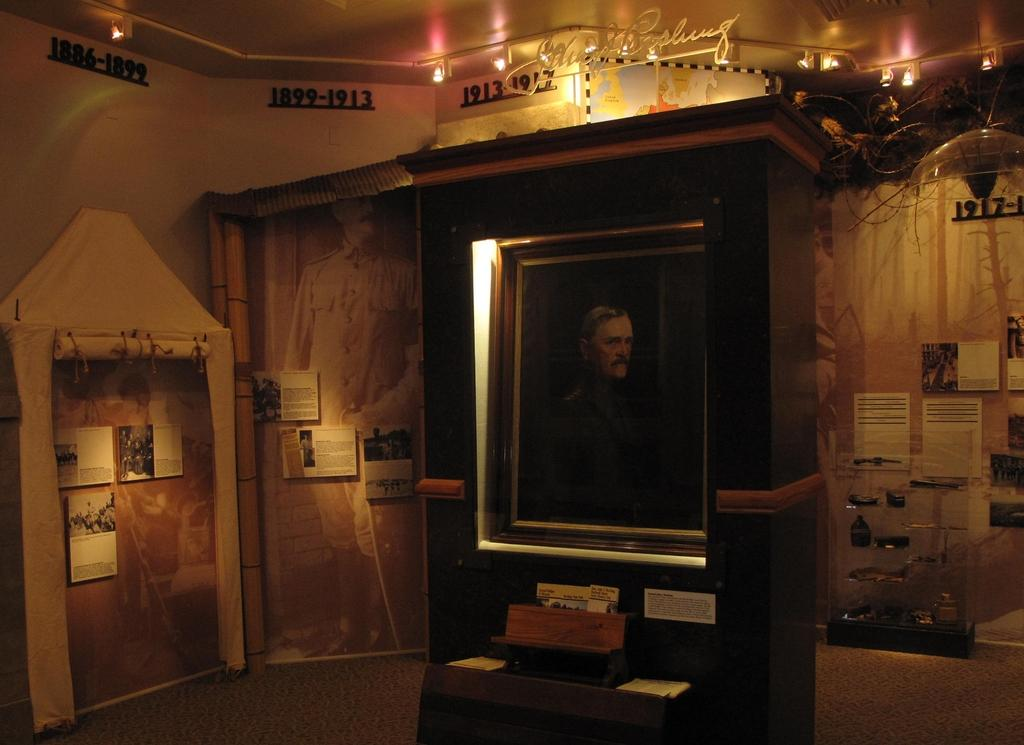What type of location is depicted in the image? The image is an inside view of a room. What can be seen on the floor of the room? There are boards in the room. What provides illumination in the room? There are lights in the room. What is on the wall of the room? There are posters on the wall. What is hanging on the wall in the room? There is a frame in the room. What other objects are present in the room? There are other objects in the room. What is written at the top of the image? There is some text at the top of the image. How many birds are flying around in the room in the image? There are no birds visible in the image; it is an inside view of a room with various objects and elements. 